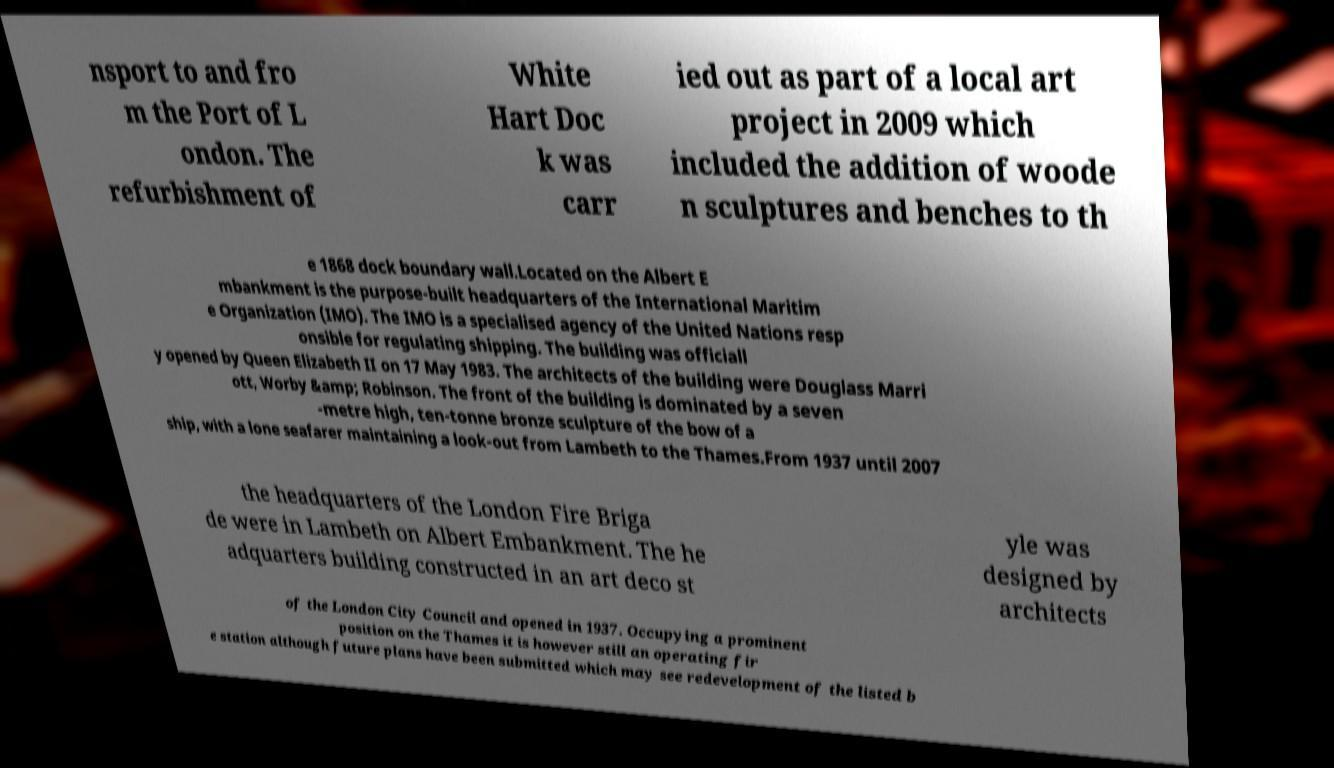Could you assist in decoding the text presented in this image and type it out clearly? nsport to and fro m the Port of L ondon. The refurbishment of White Hart Doc k was carr ied out as part of a local art project in 2009 which included the addition of woode n sculptures and benches to th e 1868 dock boundary wall.Located on the Albert E mbankment is the purpose-built headquarters of the International Maritim e Organization (IMO). The IMO is a specialised agency of the United Nations resp onsible for regulating shipping. The building was officiall y opened by Queen Elizabeth II on 17 May 1983. The architects of the building were Douglass Marri ott, Worby &amp; Robinson. The front of the building is dominated by a seven -metre high, ten-tonne bronze sculpture of the bow of a ship, with a lone seafarer maintaining a look-out from Lambeth to the Thames.From 1937 until 2007 the headquarters of the London Fire Briga de were in Lambeth on Albert Embankment. The he adquarters building constructed in an art deco st yle was designed by architects of the London City Council and opened in 1937. Occupying a prominent position on the Thames it is however still an operating fir e station although future plans have been submitted which may see redevelopment of the listed b 